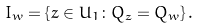Convert formula to latex. <formula><loc_0><loc_0><loc_500><loc_500>I _ { w } = \left \{ z \in U _ { 1 } \colon Q _ { z } = Q _ { w } \right \} .</formula> 